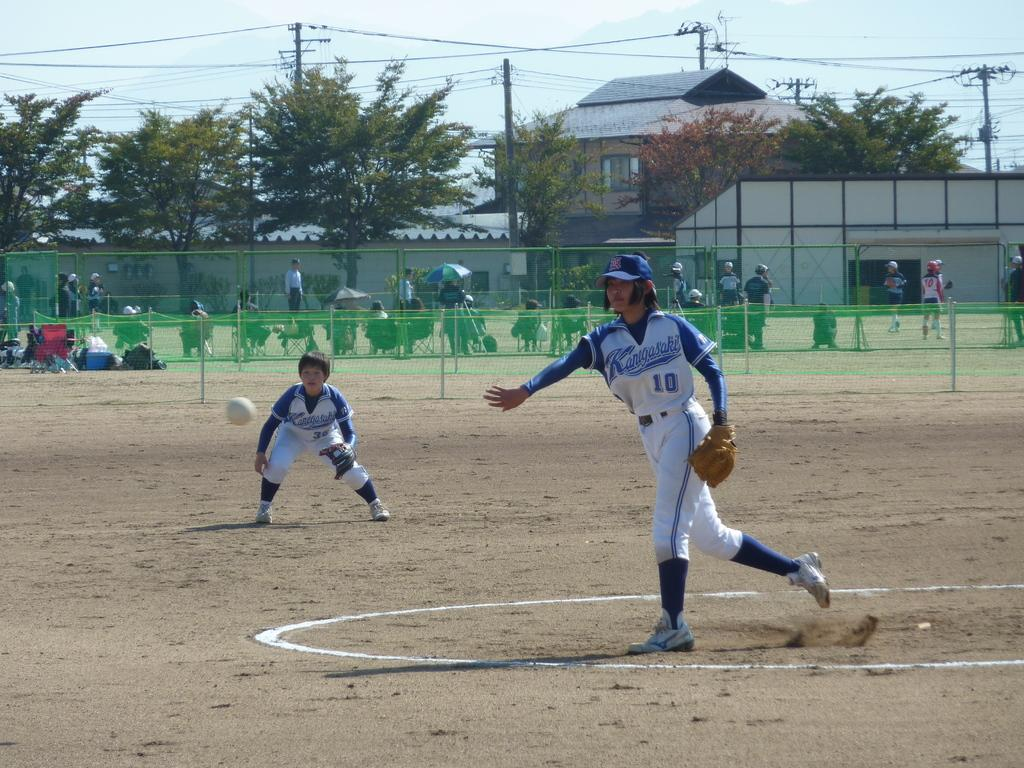<image>
Summarize the visual content of the image. Player number 10 has just thrown the ball. 